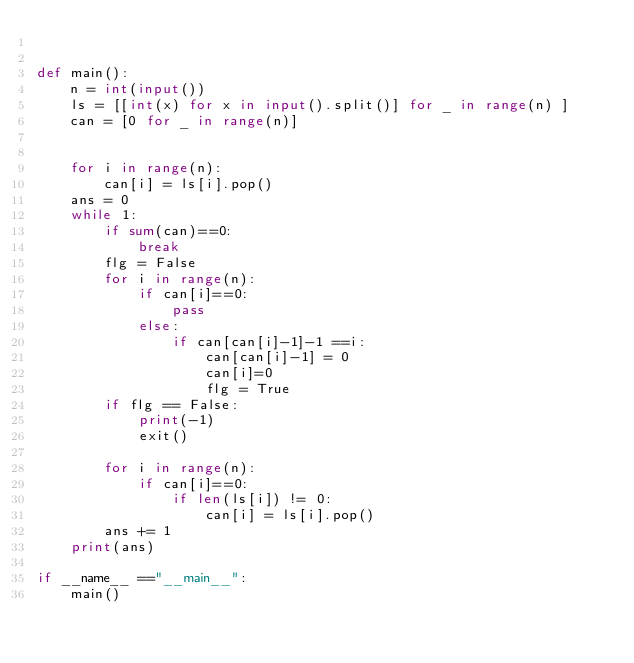Convert code to text. <code><loc_0><loc_0><loc_500><loc_500><_Python_>

def main():
    n = int(input())
    ls = [[int(x) for x in input().split()] for _ in range(n) ]
    can = [0 for _ in range(n)]


    for i in range(n):
        can[i] = ls[i].pop()
    ans = 0
    while 1:
        if sum(can)==0:
            break
        flg = False
        for i in range(n):
            if can[i]==0:
                pass
            else:
                if can[can[i]-1]-1 ==i:
                    can[can[i]-1] = 0
                    can[i]=0
                    flg = True
        if flg == False:
            print(-1)
            exit()

        for i in range(n):
            if can[i]==0:
                if len(ls[i]) != 0:
                    can[i] = ls[i].pop()
        ans += 1
    print(ans)

if __name__ =="__main__":
    main()</code> 